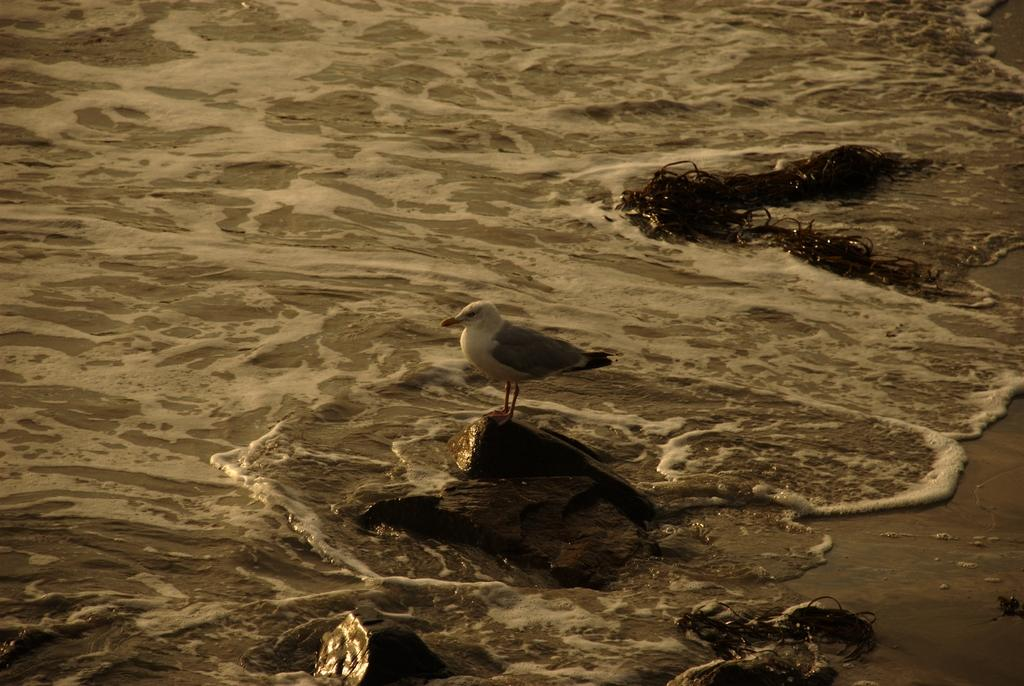What type of bird is in the image? There is a seagull bird in the image. What is the seagull bird standing on? The seagull bird is standing on a rock. What can be seen in the background of the image? There is water flowing in the image. Can you tell me how many docks are visible in the image? There are no docks present in the image. What type of system is the seagull bird a part of in the image? The seagull bird is not a part of any system in the image; it is a standalone bird. Is there a volcano visible in the image? There is no volcano present in the image. 